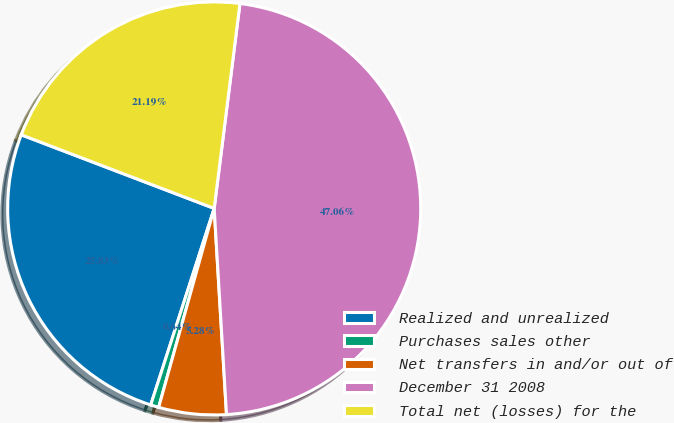Convert chart to OTSL. <chart><loc_0><loc_0><loc_500><loc_500><pie_chart><fcel>Realized and unrealized<fcel>Purchases sales other<fcel>Net transfers in and/or out of<fcel>December 31 2008<fcel>Total net (losses) for the<nl><fcel>25.83%<fcel>0.64%<fcel>5.28%<fcel>47.06%<fcel>21.19%<nl></chart> 